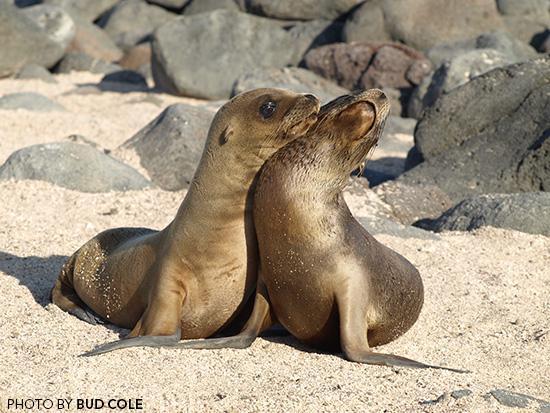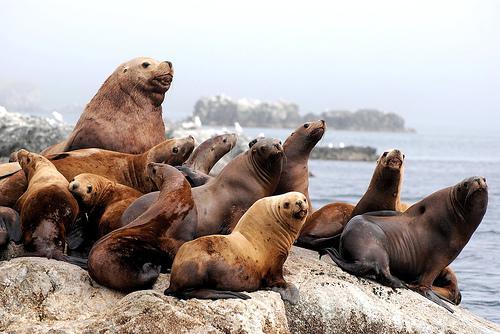The first image is the image on the left, the second image is the image on the right. For the images shown, is this caption "Two seals are bonding in one of the images." true? Answer yes or no. Yes. The first image is the image on the left, the second image is the image on the right. Assess this claim about the two images: "An image shows exactly one dark baby seal in contact with a larger, paler seal.". Correct or not? Answer yes or no. No. 